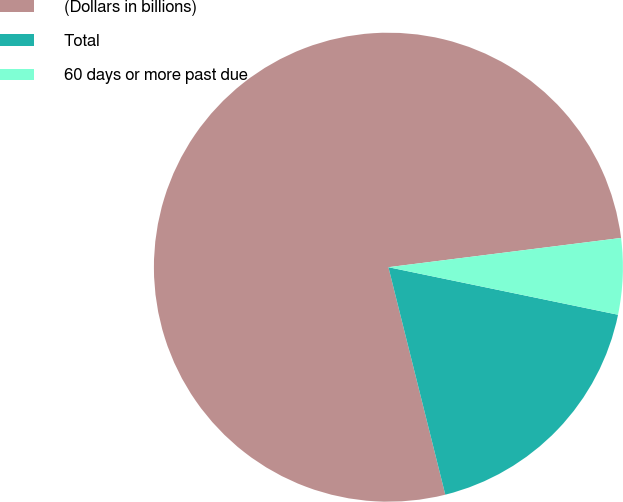Convert chart. <chart><loc_0><loc_0><loc_500><loc_500><pie_chart><fcel>(Dollars in billions)<fcel>Total<fcel>60 days or more past due<nl><fcel>76.91%<fcel>17.85%<fcel>5.24%<nl></chart> 